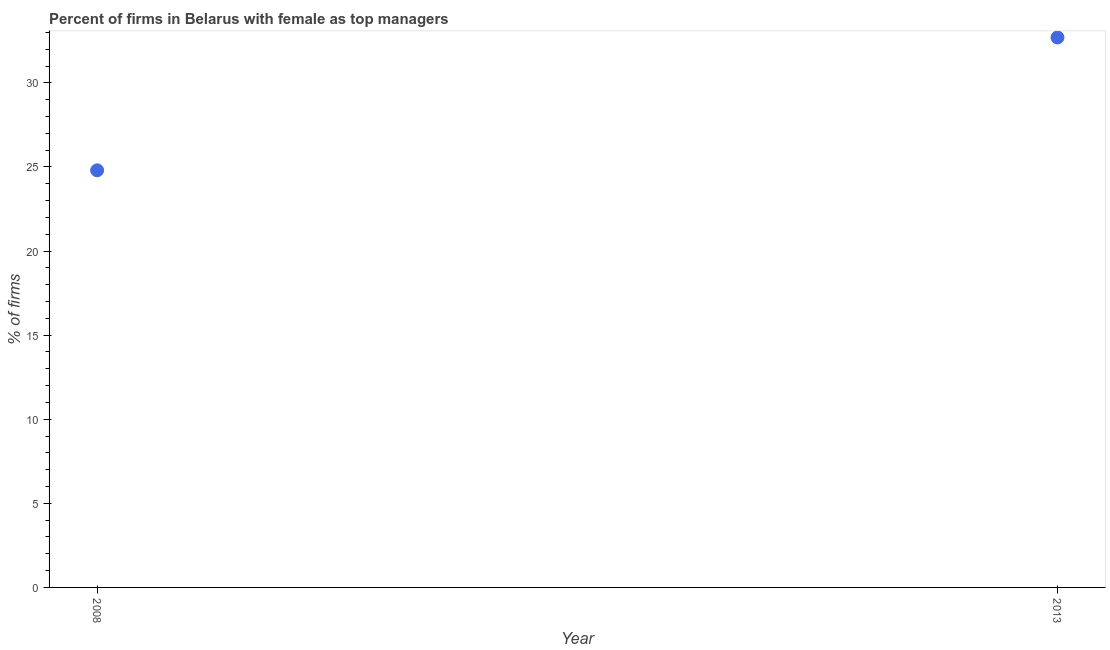What is the percentage of firms with female as top manager in 2013?
Your answer should be very brief. 32.7. Across all years, what is the maximum percentage of firms with female as top manager?
Your response must be concise. 32.7. Across all years, what is the minimum percentage of firms with female as top manager?
Offer a terse response. 24.8. What is the sum of the percentage of firms with female as top manager?
Give a very brief answer. 57.5. What is the difference between the percentage of firms with female as top manager in 2008 and 2013?
Ensure brevity in your answer.  -7.9. What is the average percentage of firms with female as top manager per year?
Your answer should be compact. 28.75. What is the median percentage of firms with female as top manager?
Ensure brevity in your answer.  28.75. In how many years, is the percentage of firms with female as top manager greater than 20 %?
Provide a succinct answer. 2. What is the ratio of the percentage of firms with female as top manager in 2008 to that in 2013?
Your response must be concise. 0.76. Is the percentage of firms with female as top manager in 2008 less than that in 2013?
Offer a terse response. Yes. Are the values on the major ticks of Y-axis written in scientific E-notation?
Provide a short and direct response. No. Does the graph contain any zero values?
Provide a short and direct response. No. Does the graph contain grids?
Offer a very short reply. No. What is the title of the graph?
Ensure brevity in your answer.  Percent of firms in Belarus with female as top managers. What is the label or title of the X-axis?
Offer a very short reply. Year. What is the label or title of the Y-axis?
Offer a very short reply. % of firms. What is the % of firms in 2008?
Your answer should be very brief. 24.8. What is the % of firms in 2013?
Your answer should be compact. 32.7. What is the difference between the % of firms in 2008 and 2013?
Make the answer very short. -7.9. What is the ratio of the % of firms in 2008 to that in 2013?
Offer a terse response. 0.76. 